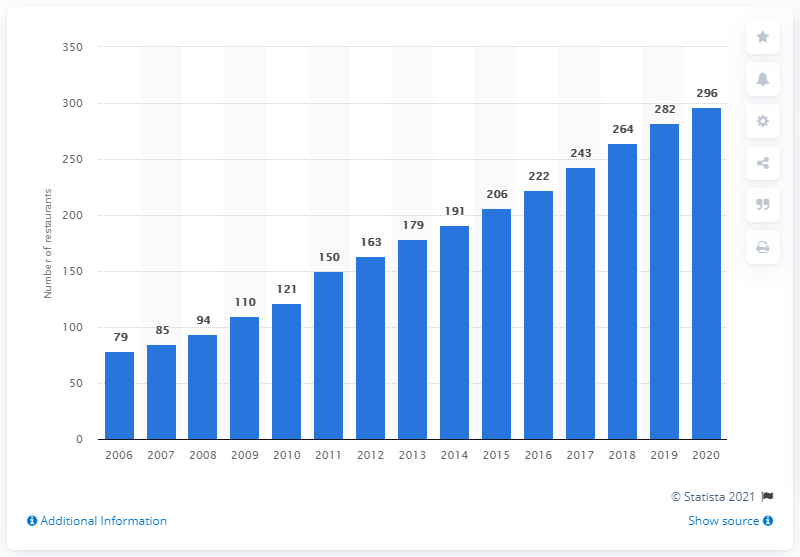Give some essential details in this illustration. In 2020, there were 296 KFC restaurants in Poland. 